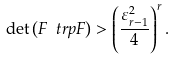Convert formula to latex. <formula><loc_0><loc_0><loc_500><loc_500>\det \left ( F ^ { \ } t r p F \right ) > \left ( \frac { \varepsilon _ { r - 1 } ^ { 2 } } { 4 } \right ) ^ { r } .</formula> 